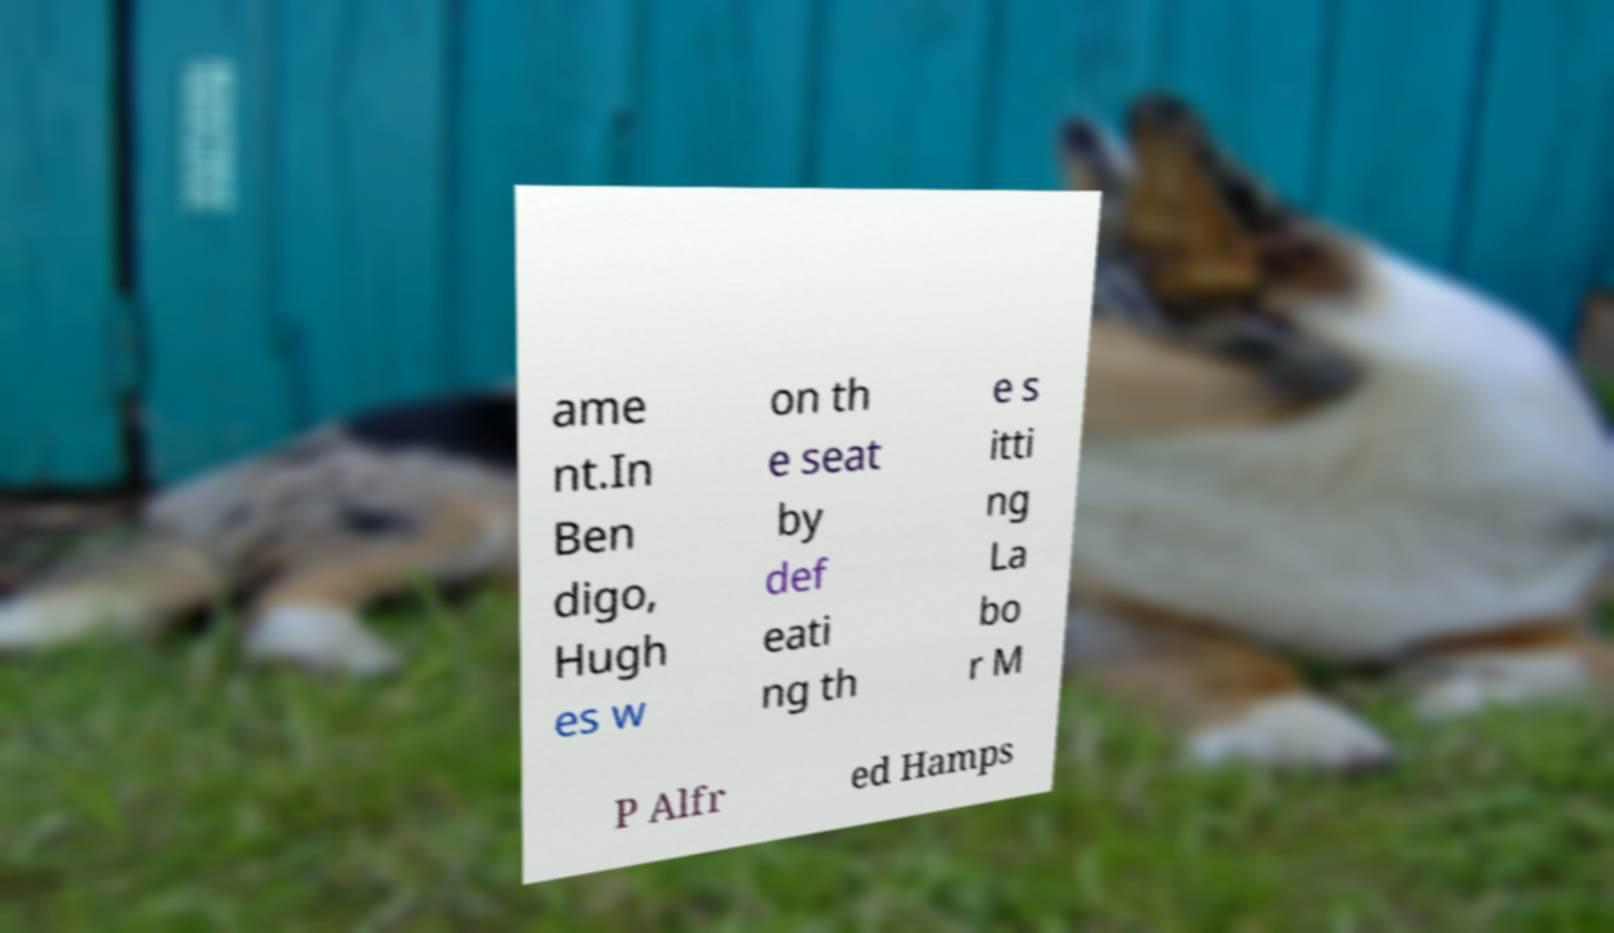For documentation purposes, I need the text within this image transcribed. Could you provide that? ame nt.In Ben digo, Hugh es w on th e seat by def eati ng th e s itti ng La bo r M P Alfr ed Hamps 